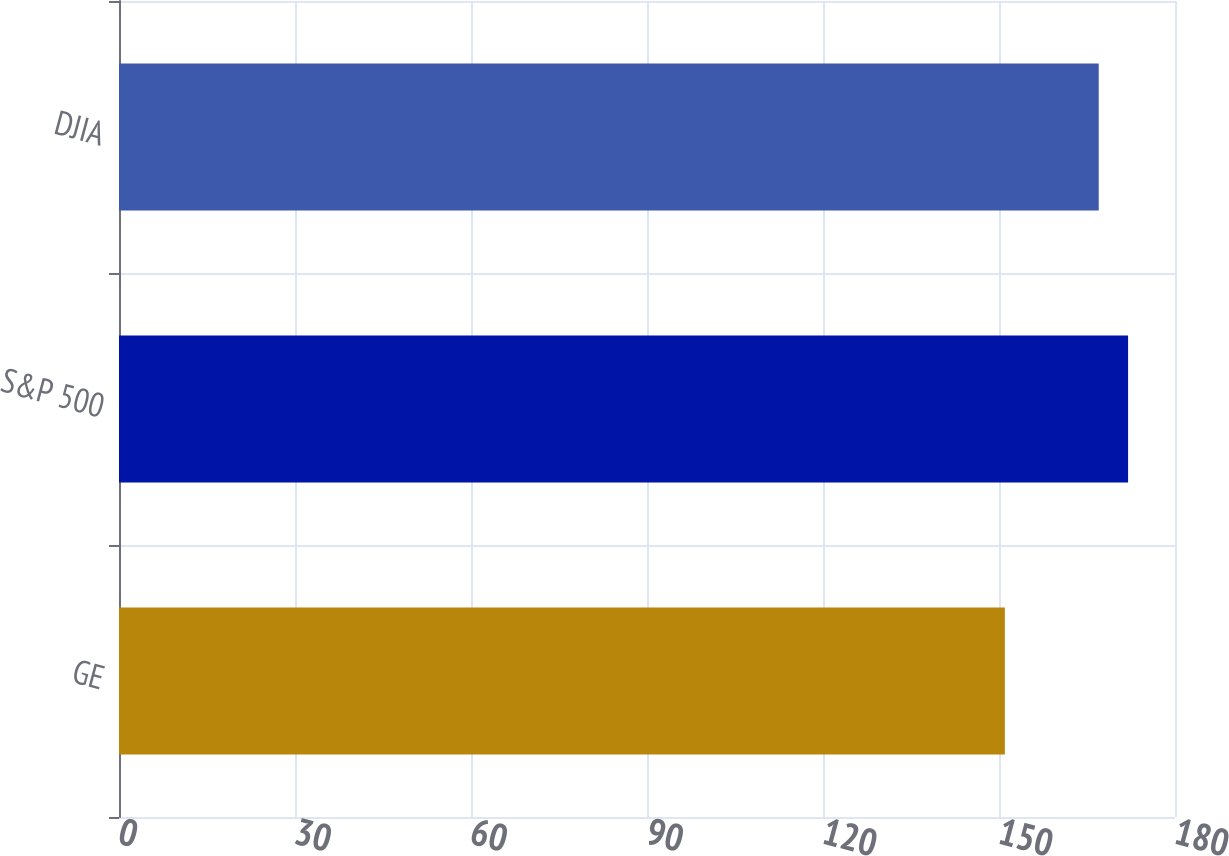<chart> <loc_0><loc_0><loc_500><loc_500><bar_chart><fcel>GE<fcel>S&P 500<fcel>DJIA<nl><fcel>151<fcel>172<fcel>167<nl></chart> 